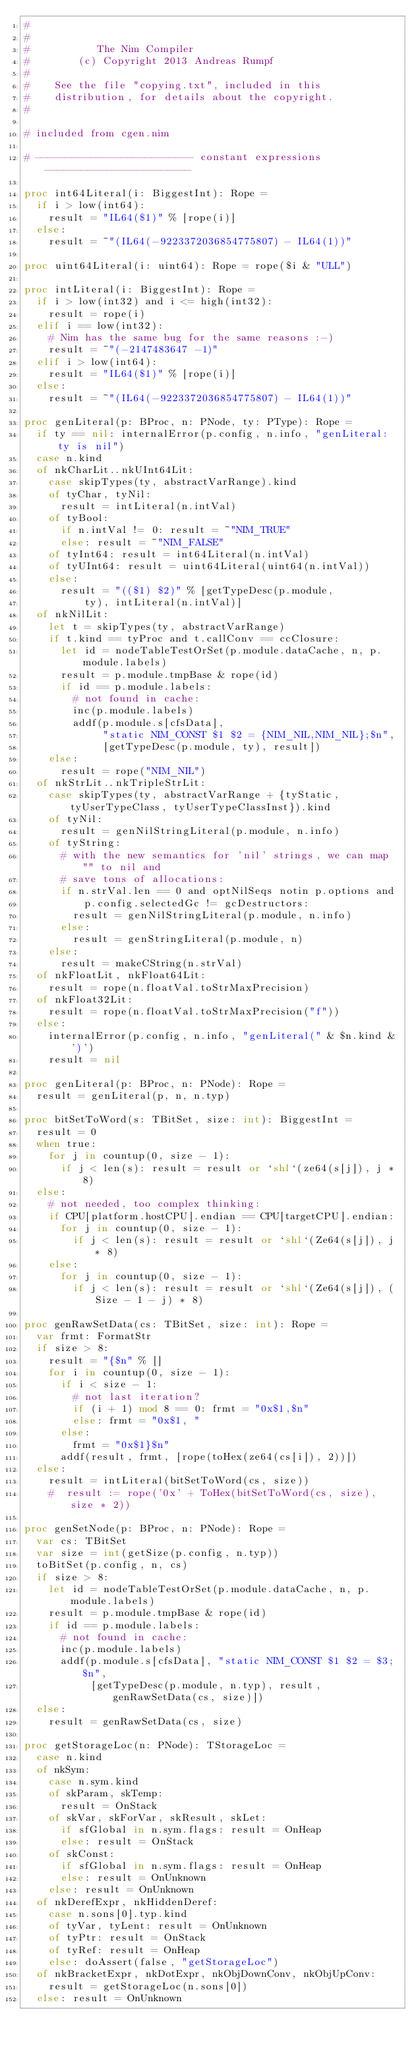<code> <loc_0><loc_0><loc_500><loc_500><_Nim_>#
#
#           The Nim Compiler
#        (c) Copyright 2013 Andreas Rumpf
#
#    See the file "copying.txt", included in this
#    distribution, for details about the copyright.
#

# included from cgen.nim

# -------------------------- constant expressions ------------------------

proc int64Literal(i: BiggestInt): Rope =
  if i > low(int64):
    result = "IL64($1)" % [rope(i)]
  else:
    result = ~"(IL64(-9223372036854775807) - IL64(1))"

proc uint64Literal(i: uint64): Rope = rope($i & "ULL")

proc intLiteral(i: BiggestInt): Rope =
  if i > low(int32) and i <= high(int32):
    result = rope(i)
  elif i == low(int32):
    # Nim has the same bug for the same reasons :-)
    result = ~"(-2147483647 -1)"
  elif i > low(int64):
    result = "IL64($1)" % [rope(i)]
  else:
    result = ~"(IL64(-9223372036854775807) - IL64(1))"

proc genLiteral(p: BProc, n: PNode, ty: PType): Rope =
  if ty == nil: internalError(p.config, n.info, "genLiteral: ty is nil")
  case n.kind
  of nkCharLit..nkUInt64Lit:
    case skipTypes(ty, abstractVarRange).kind
    of tyChar, tyNil:
      result = intLiteral(n.intVal)
    of tyBool:
      if n.intVal != 0: result = ~"NIM_TRUE"
      else: result = ~"NIM_FALSE"
    of tyInt64: result = int64Literal(n.intVal)
    of tyUInt64: result = uint64Literal(uint64(n.intVal))
    else:
      result = "(($1) $2)" % [getTypeDesc(p.module,
          ty), intLiteral(n.intVal)]
  of nkNilLit:
    let t = skipTypes(ty, abstractVarRange)
    if t.kind == tyProc and t.callConv == ccClosure:
      let id = nodeTableTestOrSet(p.module.dataCache, n, p.module.labels)
      result = p.module.tmpBase & rope(id)
      if id == p.module.labels:
        # not found in cache:
        inc(p.module.labels)
        addf(p.module.s[cfsData],
             "static NIM_CONST $1 $2 = {NIM_NIL,NIM_NIL};$n",
             [getTypeDesc(p.module, ty), result])
    else:
      result = rope("NIM_NIL")
  of nkStrLit..nkTripleStrLit:
    case skipTypes(ty, abstractVarRange + {tyStatic, tyUserTypeClass, tyUserTypeClassInst}).kind
    of tyNil:
      result = genNilStringLiteral(p.module, n.info)
    of tyString:
      # with the new semantics for 'nil' strings, we can map "" to nil and
      # save tons of allocations:
      if n.strVal.len == 0 and optNilSeqs notin p.options and
          p.config.selectedGc != gcDestructors:
        result = genNilStringLiteral(p.module, n.info)
      else:
        result = genStringLiteral(p.module, n)
    else:
      result = makeCString(n.strVal)
  of nkFloatLit, nkFloat64Lit:
    result = rope(n.floatVal.toStrMaxPrecision)
  of nkFloat32Lit:
    result = rope(n.floatVal.toStrMaxPrecision("f"))
  else:
    internalError(p.config, n.info, "genLiteral(" & $n.kind & ')')
    result = nil

proc genLiteral(p: BProc, n: PNode): Rope =
  result = genLiteral(p, n, n.typ)

proc bitSetToWord(s: TBitSet, size: int): BiggestInt =
  result = 0
  when true:
    for j in countup(0, size - 1):
      if j < len(s): result = result or `shl`(ze64(s[j]), j * 8)
  else:
    # not needed, too complex thinking:
    if CPU[platform.hostCPU].endian == CPU[targetCPU].endian:
      for j in countup(0, size - 1):
        if j < len(s): result = result or `shl`(Ze64(s[j]), j * 8)
    else:
      for j in countup(0, size - 1):
        if j < len(s): result = result or `shl`(Ze64(s[j]), (Size - 1 - j) * 8)

proc genRawSetData(cs: TBitSet, size: int): Rope =
  var frmt: FormatStr
  if size > 8:
    result = "{$n" % []
    for i in countup(0, size - 1):
      if i < size - 1:
        # not last iteration?
        if (i + 1) mod 8 == 0: frmt = "0x$1,$n"
        else: frmt = "0x$1, "
      else:
        frmt = "0x$1}$n"
      addf(result, frmt, [rope(toHex(ze64(cs[i]), 2))])
  else:
    result = intLiteral(bitSetToWord(cs, size))
    #  result := rope('0x' + ToHex(bitSetToWord(cs, size), size * 2))

proc genSetNode(p: BProc, n: PNode): Rope =
  var cs: TBitSet
  var size = int(getSize(p.config, n.typ))
  toBitSet(p.config, n, cs)
  if size > 8:
    let id = nodeTableTestOrSet(p.module.dataCache, n, p.module.labels)
    result = p.module.tmpBase & rope(id)
    if id == p.module.labels:
      # not found in cache:
      inc(p.module.labels)
      addf(p.module.s[cfsData], "static NIM_CONST $1 $2 = $3;$n",
           [getTypeDesc(p.module, n.typ), result, genRawSetData(cs, size)])
  else:
    result = genRawSetData(cs, size)

proc getStorageLoc(n: PNode): TStorageLoc =
  case n.kind
  of nkSym:
    case n.sym.kind
    of skParam, skTemp:
      result = OnStack
    of skVar, skForVar, skResult, skLet:
      if sfGlobal in n.sym.flags: result = OnHeap
      else: result = OnStack
    of skConst:
      if sfGlobal in n.sym.flags: result = OnHeap
      else: result = OnUnknown
    else: result = OnUnknown
  of nkDerefExpr, nkHiddenDeref:
    case n.sons[0].typ.kind
    of tyVar, tyLent: result = OnUnknown
    of tyPtr: result = OnStack
    of tyRef: result = OnHeap
    else: doAssert(false, "getStorageLoc")
  of nkBracketExpr, nkDotExpr, nkObjDownConv, nkObjUpConv:
    result = getStorageLoc(n.sons[0])
  else: result = OnUnknown
</code> 